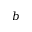Convert formula to latex. <formula><loc_0><loc_0><loc_500><loc_500>b</formula> 